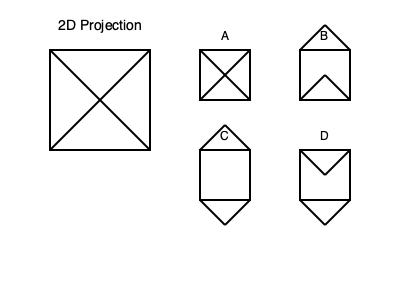Which 3D object (A, B, C, or D) correctly matches the given 2D projection? Imagine you're swiping through profile pictures on a dating app, but instead of faces, you're trying to match these shapes. Which one would you "swipe right" on? To solve this problem, we need to mentally rotate each 3D object and compare it to the given 2D projection. Let's analyze each option step-by-step:

1. First, observe the 2D projection. It shows a square with two diagonal lines crossing from corner to corner.

2. Now, let's examine each 3D object:

   A: This object has a square base with four edges meeting at a point above the center. If viewed from directly above, it would match the 2D projection.
   
   B: This object has a square base with four edges meeting at a point below the center. When viewed from above, it would not match the projection.
   
   C: This object has a square base with two edges pointing up and two pointing down. It would not match the projection from any angle.
   
   D: This object has a square base with four edges meeting at a point below the center, similar to B but rotated. It would not match the projection.

3. By process of elimination, we can see that only object A would produce the given 2D projection when viewed from directly above.

4. To relate this to the persona: Just as you might need to look beyond surface-level profile pictures in online dating to find a genuine match, here you need to look beyond the initial 3D appearances to find the true match for the 2D projection.
Answer: A 